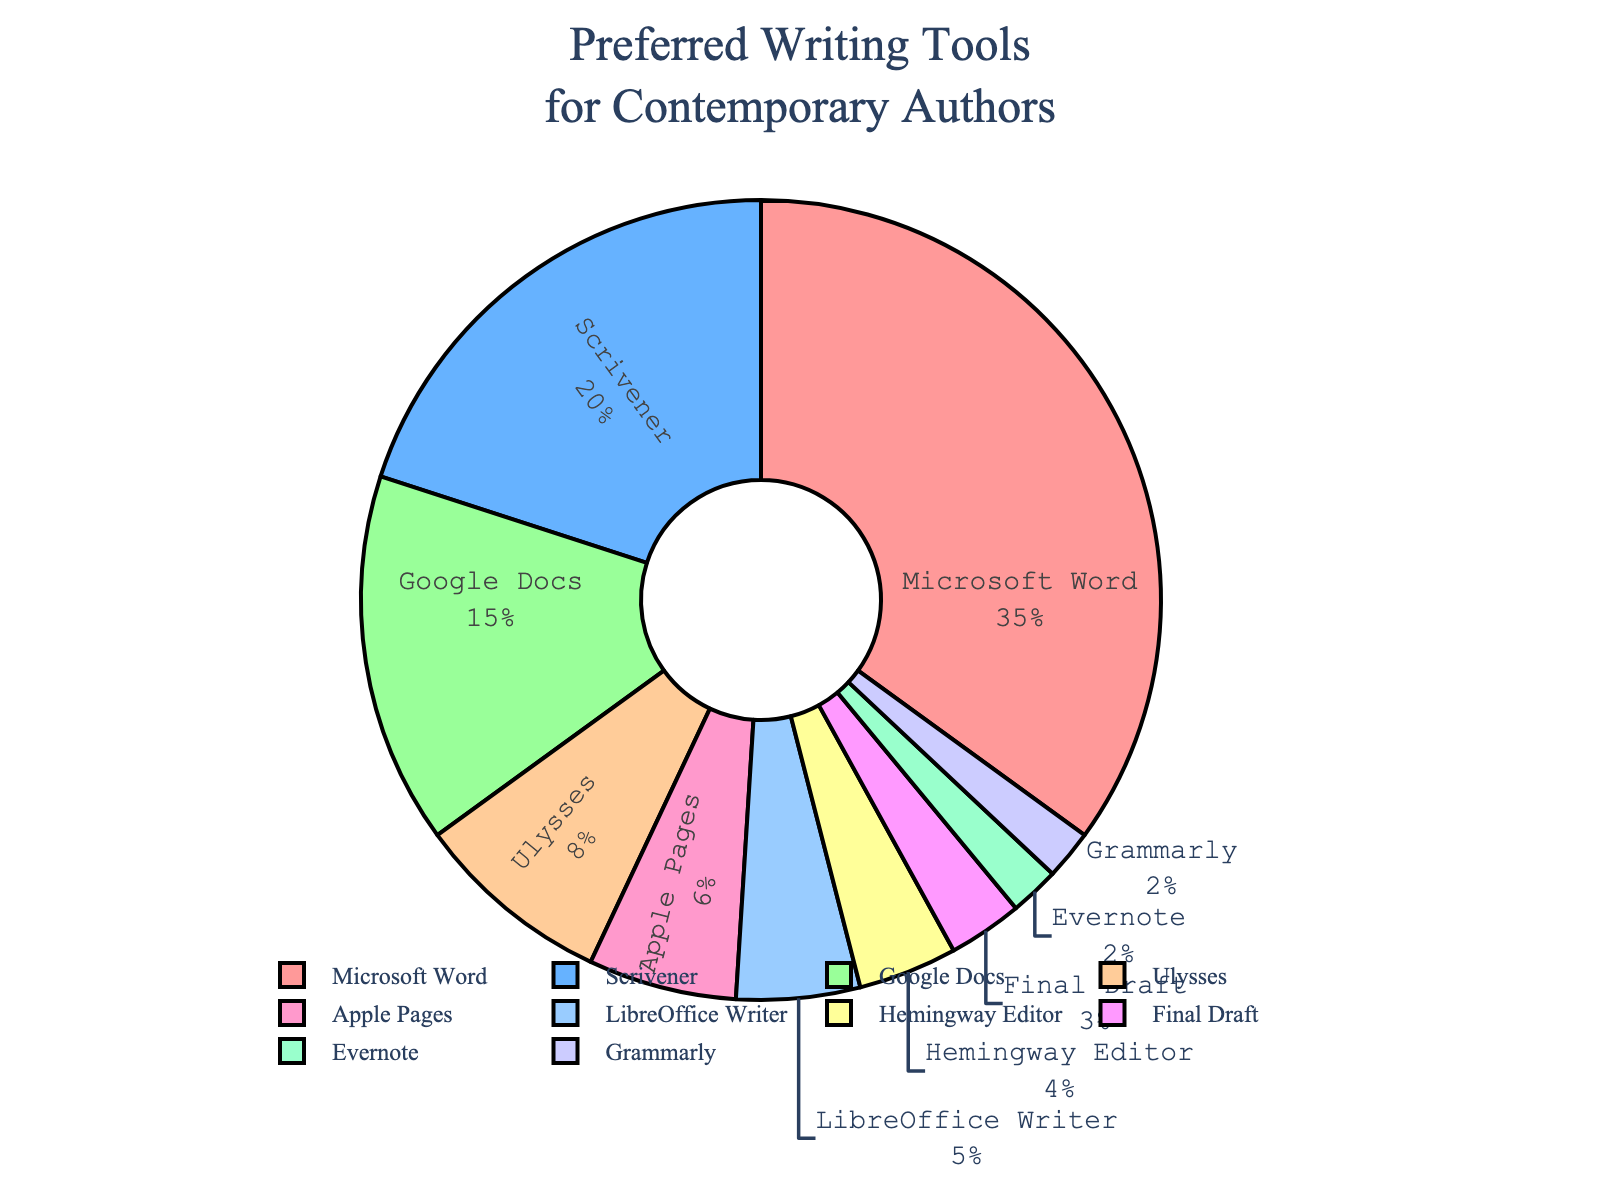What percentage of contemporary authors prefer Microsoft Word? According to the pie chart, Microsoft Word is the segment labeled with 35%, which is the highest percentage among all listed tools.
Answer: 35% Which writing tool is preferred more by authors, Google Docs or Ulysses? To determine which tool is preferred more, compare the percentages. Google Docs has 15% and Ulysses has 8%. Google Docs has a higher percentage.
Answer: Google Docs How much larger is the percentage of authors using Scrivener compared to those using LibreOffice Writer? Scrivener is used by 20% of authors, while LibreOffice Writer is used by 5%. The difference is 20% - 5% = 15%.
Answer: 15% What is the total percentage of authors using Microsoft Word, Scrivener, and Google Docs combined? Sum the percentages of Microsoft Word (35%), Scrivener (20%), and Google Docs (15%). The total is 35% + 20% + 15% = 70%.
Answer: 70% How does the usage of Hemingway Editor compare to Final Draft? Hemingway Editor is preferred by 4% of authors and Final Draft by 3%. Hemingway Editor is used by 1% more authors than Final Draft.
Answer: 1% more What is the least preferred writing tool among the listed options? The writing tools with the smallest percentage are Evernote and Grammarly, each with 2%.
Answer: Evernote and Grammarly How many tools are preferred by more than 10% of contemporary authors? Microsoft Word, Scrivener, and Google Docs have percentages above 10%. Counting these tools results in three.
Answer: 3 tools If you combine the percentages of Apple Pages and Ulysses, what is the resulting total? Add the percentages of Apple Pages (6%) and Ulysses (8%). The combined total is 6% + 8% = 14%.
Answer: 14% What is the difference in usage percentage between the most and least preferred tools? The most preferred tool, Microsoft Word, has 35%, and the least preferred tools, Evernote and Grammarly, both have 2%. The difference is 35% - 2% = 33%.
Answer: 33% 